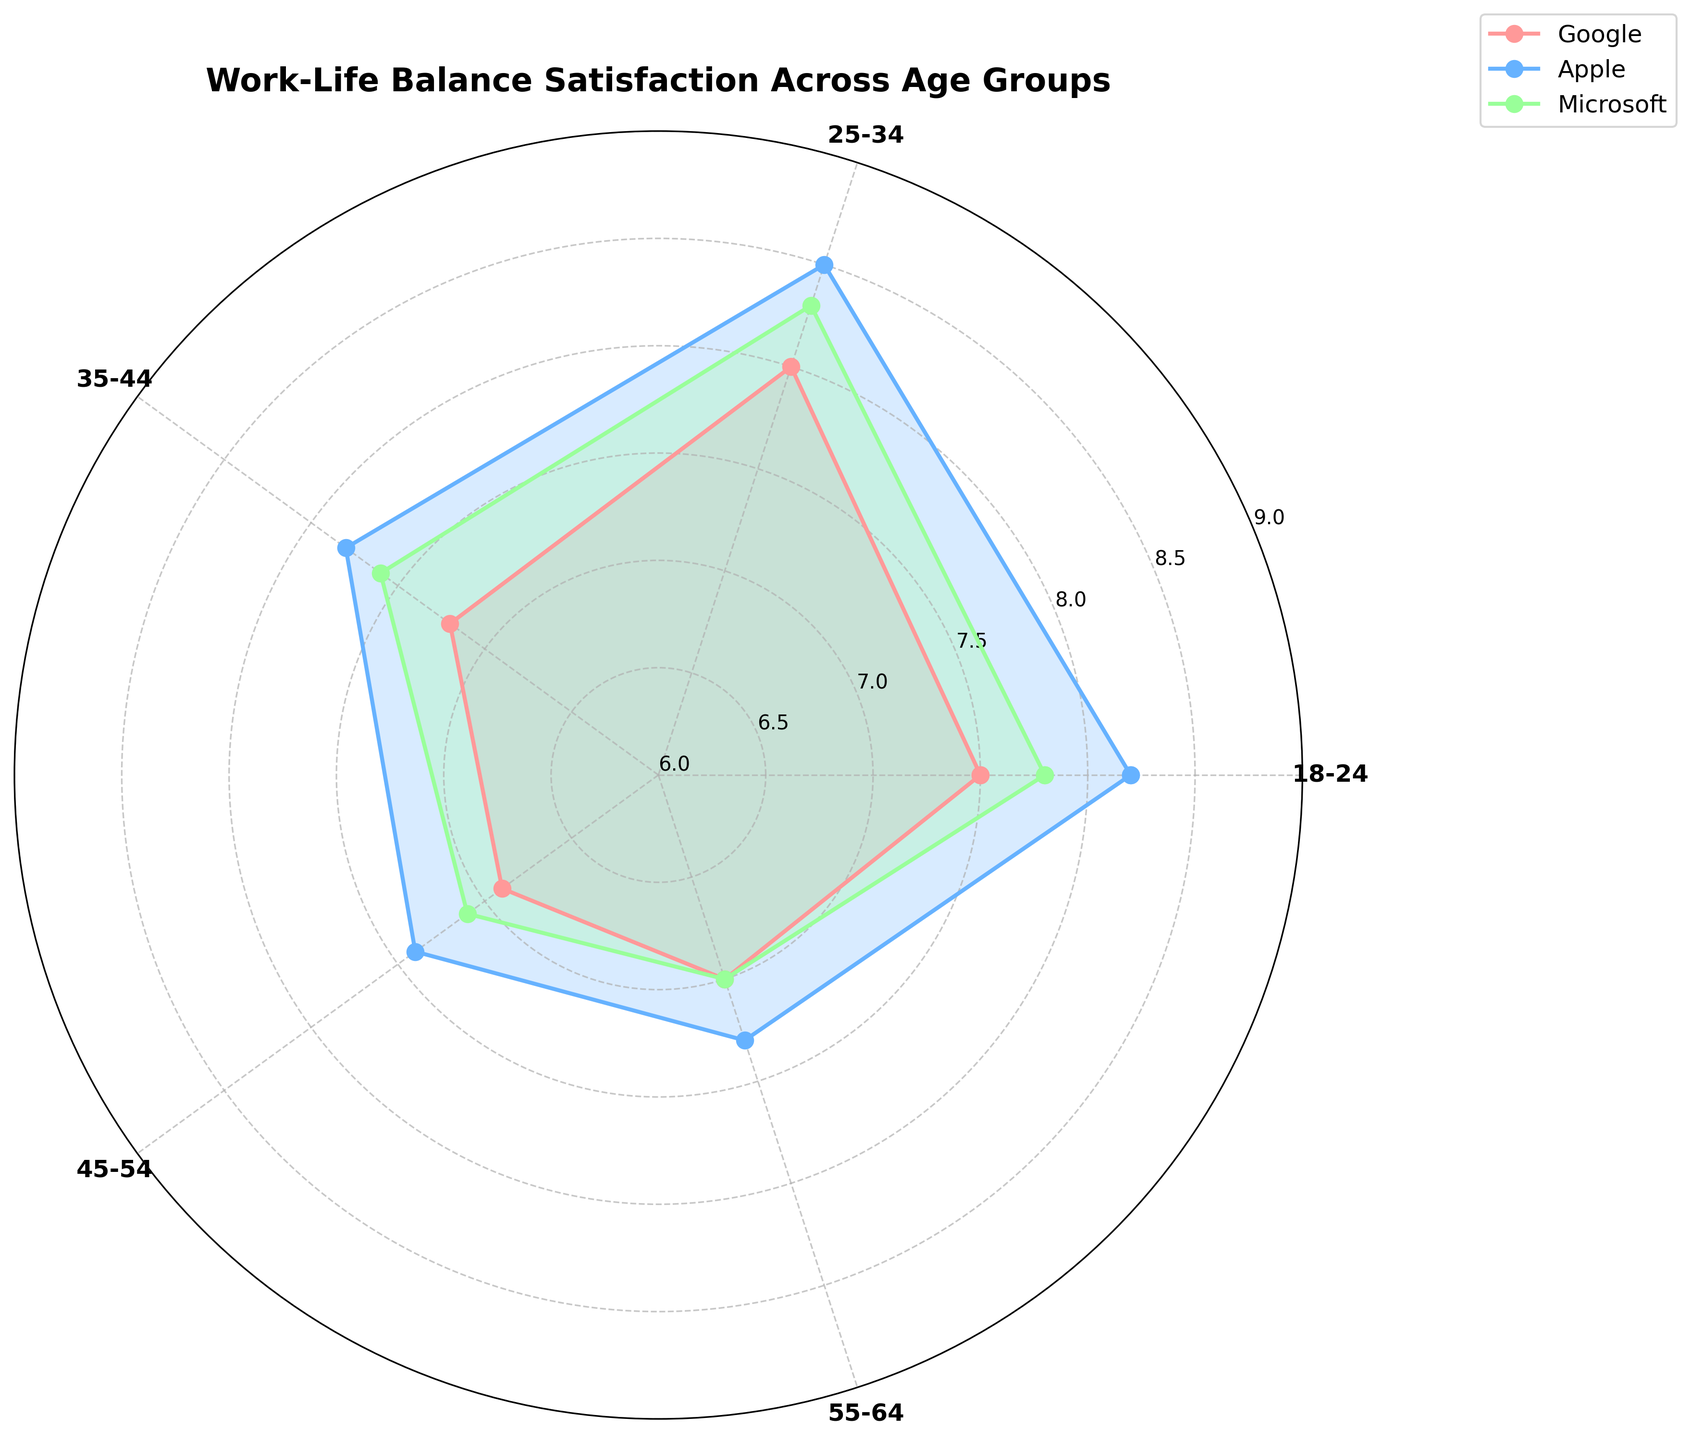What's the title of the plot? The title is found at the top of the plot; it helps in understanding what the plot is about.
Answer: Work-Life Balance Satisfaction Across Age Groups What color represents Google in the plot? Each company is represented by a unique color, which differentiates it from others. Google is represented by a pinkish color.
Answer: Pinkish Which company has the highest work-life balance rating for the age group 25-34? By examining the values for each age group, it can be determined which company has the highest rating. For 25-34, Apple has the highest rating.
Answer: Apple What's the average work-life balance rating for the 35-44 age group? The ratings for 35-44 are Google: 7.2, Apple: 7.8, and Microsoft: 7.6. Average calculation: (7.2 + 7.8 + 7.6) / 3.
Answer: 7.53 Which age group has the lowest work-life balance rating overall? Compare the lowest ratings for each age group and identify the smallest. For 45-54, Google has the lowest rating of 6.9.
Answer: 45-54 How does Apple's rating for 18-24 compare to that of Microsoft's? Look at the ratings for Apple and Microsoft in the 18-24 age group. Apple: 8.2, Microsoft: 7.8. Compare these two values.
Answer: Apple's rating is higher What is the overall pattern of work-life balance ratings as age increases? Assess the trend from youngest to oldest age groups by observing the ratings for each. Generally, ratings tend to decrease with increasing age.
Answer: Decreasing trend Which company shows the most variability in work-life balance satisfaction ratings across age groups? Examine the differences in ratings for each company across all age groups. Apple has the highest range from 7.3 to 8.5.
Answer: Apple If you sum the work-life balance ratings for Microsoft across all age groups, what is the total? Add the ratings for Microsoft across all age groups: 7.8 + 8.3 + 7.6 + 7.1 + 7.0. Total is 37.8.
Answer: 37.8 In which age group does Google have the lowest rating and what is the value? Compare Google's ratings across age groups to find the lowest one. The lowest rating is in the 45-54 age group, with a value of 6.9.
Answer: 45-54, 6.9 What are the approximate y-tick interval steps shown in the figure? Look at the y-axis and measure the gaps between ticks to find the intervals. The intervals on the y-axis are approximately 0.5.
Answer: 0.5 